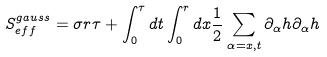Convert formula to latex. <formula><loc_0><loc_0><loc_500><loc_500>S ^ { g a u s s } _ { e f f } = \sigma r \tau + \int ^ { \tau } _ { 0 } d t \int ^ { r } _ { 0 } d x \frac { 1 } { 2 } \sum _ { \alpha = x , t } \partial _ { \alpha } h \partial _ { \alpha } h</formula> 